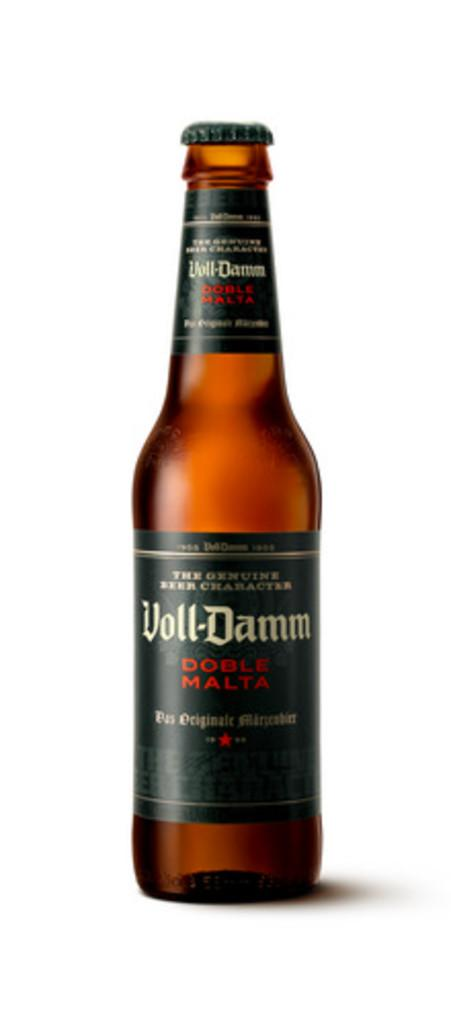Provide a one-sentence caption for the provided image. a bottle of Voll-Damm liquor to open. 